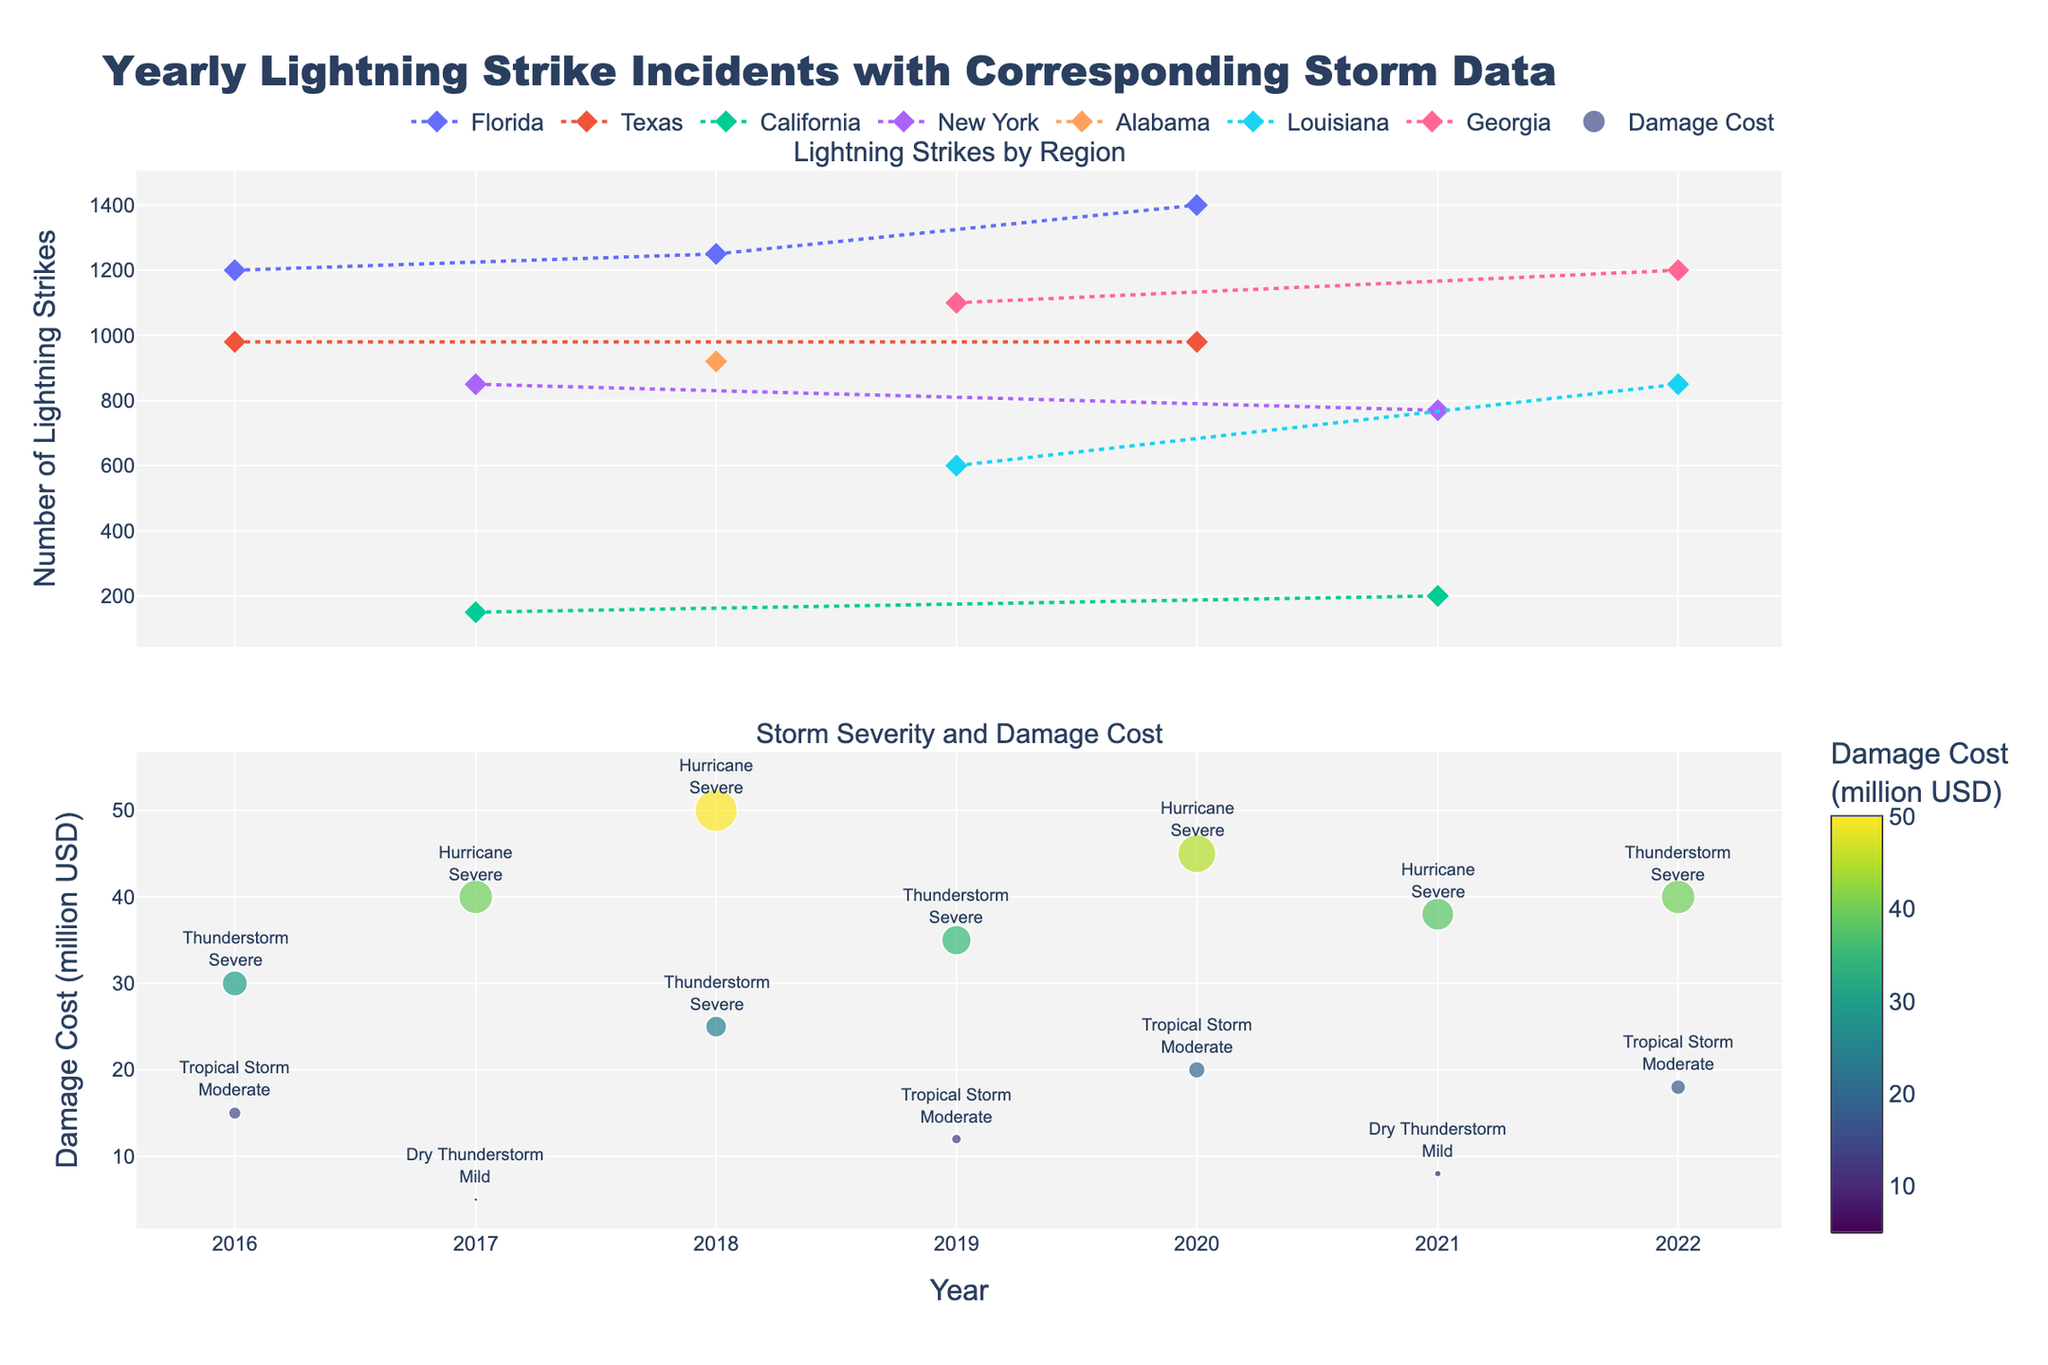how many regions are plotted in the lightning strikes subplot? Look at the legend in the "Lightning Strikes by Region" subplot. Each region's name is listed, representing the plotted data.
Answer: 6 what year had the highest number of lightning strikes in Florida? In the lightning strikes subplot, locate the data points for Florida. The highest point is in the year 2020 with 1400 strikes.
Answer: 2020 compare the average number of lightning strikes in Georgia and Texas. Which is higher? Calculate the average number of strikes for each state using the data points from the lightning strikes subplot. Georgia: (1100 + 1200) / 2 = 1150. Texas: (980 + 980) / 2 = 980. Georgia has a higher average.
Answer: Georgia which year had the highest total damage cost across all regions? In the storm severity and damage cost subplot, identify the year with the largest marker. That year is 2018 with a total of 50 million USD.
Answer: 2018 how many years featured hurricanes with severe severity? Look through the annotations in the storm severity and damage cost subplot for hurricane events marked as "Severe." There are 3 occurrences (2017, 2018, and 2020).
Answer: 3 what is the damage cost relationship between the highest and lowest storm severity events in a single year? Identify the highest and lowest storm severity events in the storm severity and damage cost subplot. Compare their respective damage costs. Example: In 2018, the highest cost is 50 million USD (hurricane, severe) and the lowest is 25 million USD (thunderstorm, severe). The relationship is the highest is double the lowest.
Answer: highest is double which region experienced the least number of lightning strikes in any given year? In the lightning strikes subplot, find the lowest data point. California has the least number of strikes, with 150 in 2017.
Answer: California, 150 compare the damage costs for hurricanes in New York in 2017 and 2021. Which year had higher costs? In the storm severity and damage cost subplot, compare the damage cost markers and annotations for New York in 2017 and 2021. 2017: $40 million, 2021: $38 million. 2017 had higher costs.
Answer: 2017 is there a correlation between the number of lightning strikes and storm severity? Examine both subplots for pattern overlaps. There isn't a clear direct correlation visually between lightning strikes counts and storm severity annotations.
Answer: no clear correlation how does the storm type distribution vary across different years? Review the annotations in the storm severity and damage cost subplot to observe the variety and frequency of storm types each year (e.g., tropical storms, hurricanes, thunderstorms). The distribution shows a mix of types with frequent appearances by tropical storms and hurricanes.
Answer: varied distribution 